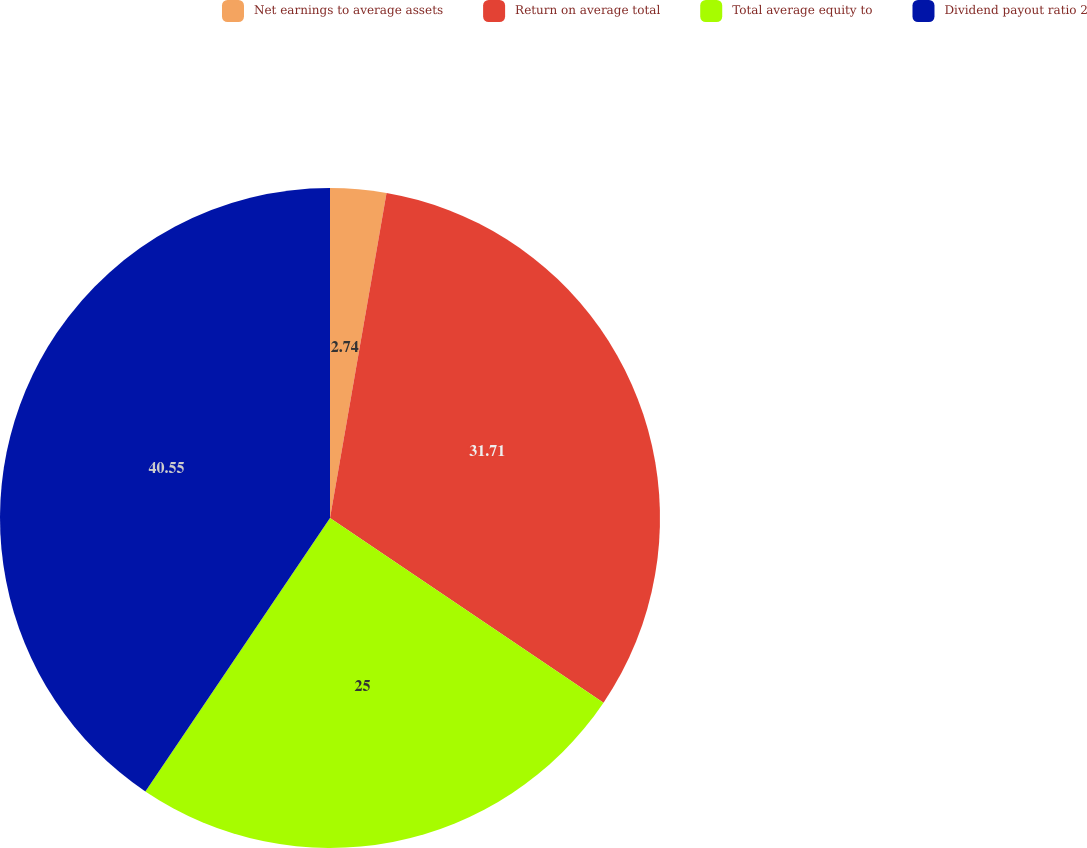<chart> <loc_0><loc_0><loc_500><loc_500><pie_chart><fcel>Net earnings to average assets<fcel>Return on average total<fcel>Total average equity to<fcel>Dividend payout ratio 2<nl><fcel>2.74%<fcel>31.71%<fcel>25.0%<fcel>40.55%<nl></chart> 